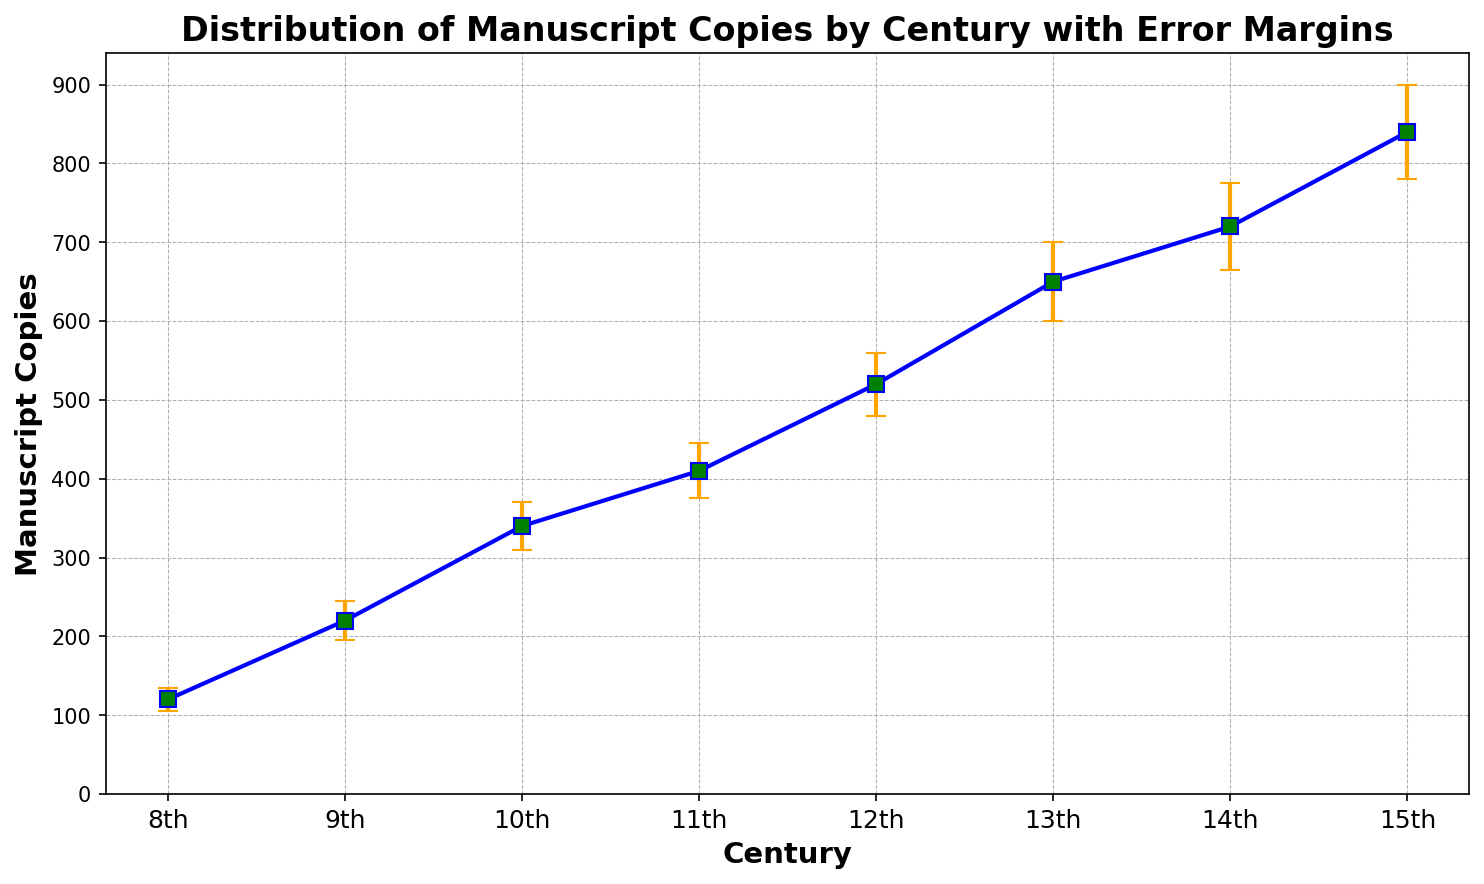Which century has the highest number of manuscript copies? The 15th century has the highest point in the figure, indicating it has the highest number of manuscript copies.
Answer: 15th century What is the approximate difference in the number of manuscript copies between the 8th and 15th centuries? The figure shows the number of manuscript copies in the 8th century is 120 and in the 15th century is 840. The difference is therefore 840 - 120 = 720.
Answer: 720 Which century shows the greatest uncertainty in dating, as indicated by the error margins? The lengths of the error bars indicate uncertainty. The error bar for the 15th century is the longest, showing the greatest uncertainty (60).
Answer: 15th century How does the number of manuscript copies change from the 11th to the 12th century? The figure shows the 11th century has 410 manuscript copies and the 12th century has 520. The number of copies increases by 520 - 410 = 110.
Answer: 110 increase Which century has more manuscript copies: the 9th or the 13th century? The figure shows the 9th century has 220 manuscript copies while the 13th century has 650. Thus, the 13th century has more manuscript copies.
Answer: 13th century What is the sum of the error margins for the 8th and 14th centuries? The error margin for the 8th century is 15, and for the 14th century is 55. Their sum is 15 + 55 = 70.
Answer: 70 Do the number of manuscript copies grow steadily over the centuries observed? The plot shows a generally increasing trend in manuscript copies from the 8th to the 15th century. It indicates a steady growth over the centuries.
Answer: Yes What is the average number of manuscript copies over all the centuries shown? Sum the manuscript copies (120 + 220 + 340 + 410 + 520 + 650 + 720 + 840 = 3820) and divide by the number of centuries (8). The average is 3820 / 8 = 477.5.
Answer: 477.5 Which centuries have fewer than 500 manuscript copies? The figure shows that the 8th (120), 9th (220), 10th (340), and 11th (410) centuries have fewer than 500 manuscript copies.
Answer: 8th, 9th, 10th, and 11th If the error margin for the 12th century were doubled, what would the new error margin be? The current error margin for the 12th century is 40. Doubling it results in 40 * 2 = 80.
Answer: 80 